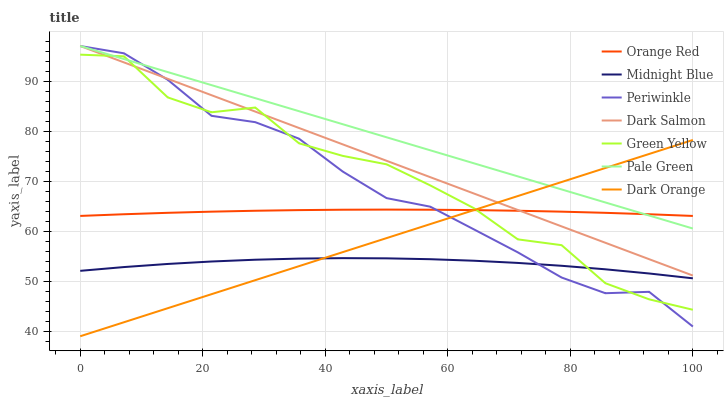Does Midnight Blue have the minimum area under the curve?
Answer yes or no. Yes. Does Pale Green have the maximum area under the curve?
Answer yes or no. Yes. Does Dark Salmon have the minimum area under the curve?
Answer yes or no. No. Does Dark Salmon have the maximum area under the curve?
Answer yes or no. No. Is Dark Orange the smoothest?
Answer yes or no. Yes. Is Green Yellow the roughest?
Answer yes or no. Yes. Is Midnight Blue the smoothest?
Answer yes or no. No. Is Midnight Blue the roughest?
Answer yes or no. No. Does Dark Orange have the lowest value?
Answer yes or no. Yes. Does Midnight Blue have the lowest value?
Answer yes or no. No. Does Periwinkle have the highest value?
Answer yes or no. Yes. Does Midnight Blue have the highest value?
Answer yes or no. No. Is Midnight Blue less than Pale Green?
Answer yes or no. Yes. Is Orange Red greater than Midnight Blue?
Answer yes or no. Yes. Does Pale Green intersect Green Yellow?
Answer yes or no. Yes. Is Pale Green less than Green Yellow?
Answer yes or no. No. Is Pale Green greater than Green Yellow?
Answer yes or no. No. Does Midnight Blue intersect Pale Green?
Answer yes or no. No. 